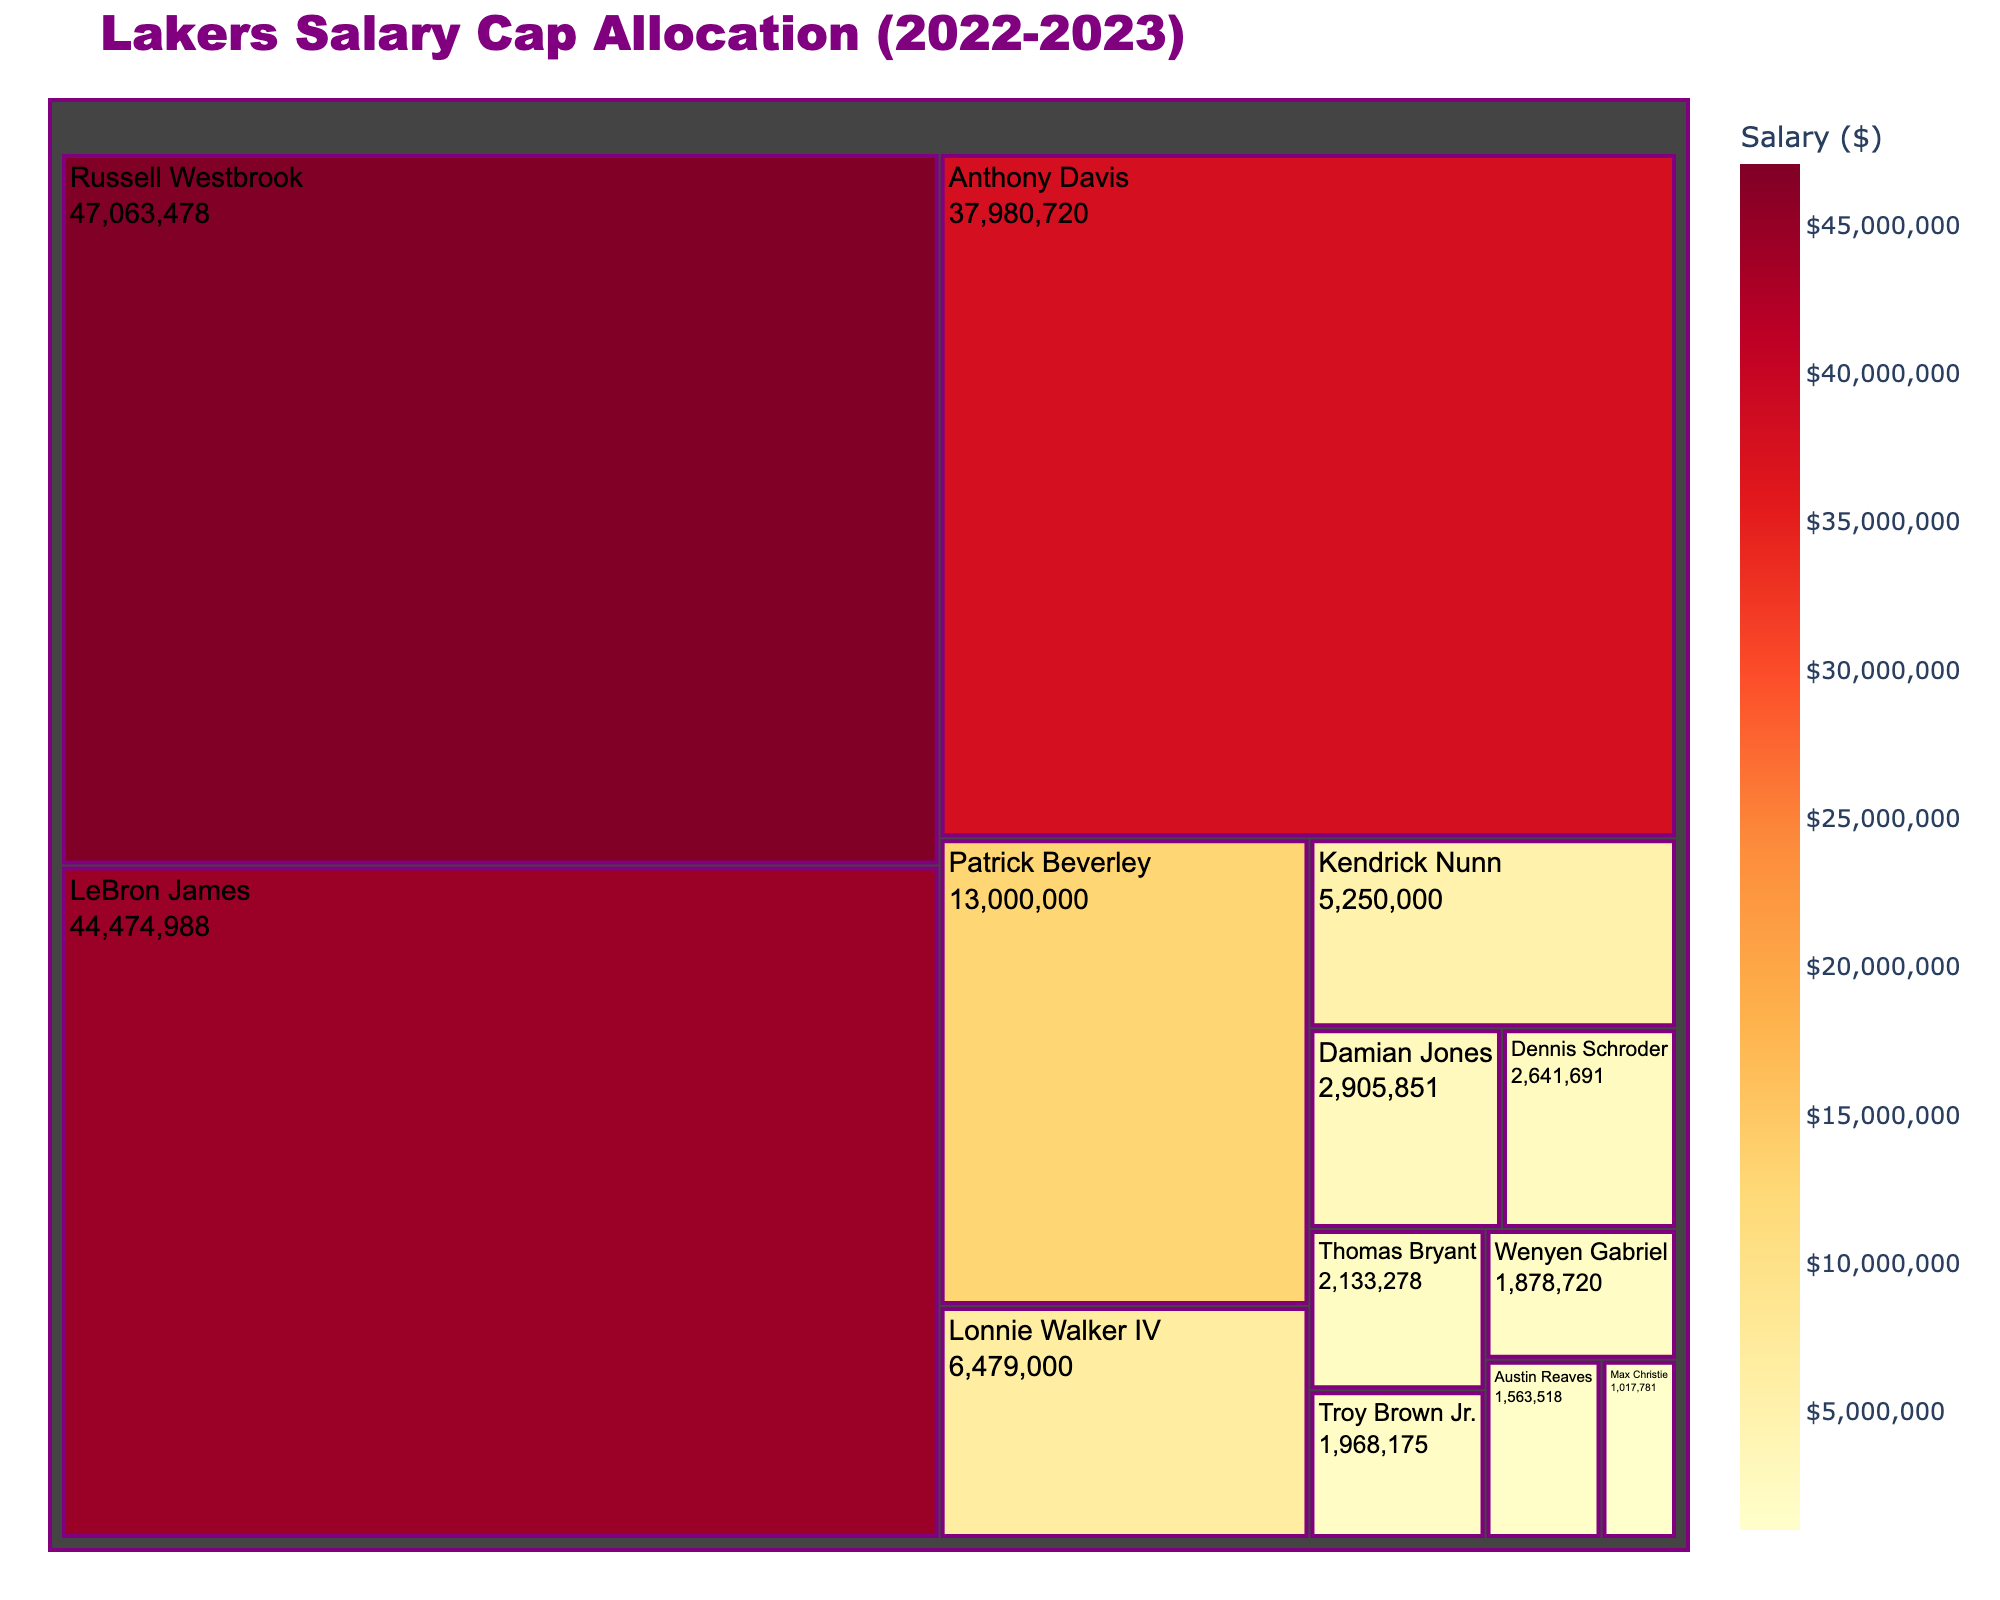What's the title of the figure? The title is usually found at the top of the figure. In this case, it reads "Lakers Salary Cap Allocation (2022-2023)".
Answer: Lakers Salary Cap Allocation (2022-2023) Which player has the highest salary? The largest and darkest colored block represents the player with the highest salary. In this treemap, Russell Westbrook's block is the largest and darkest.
Answer: Russell Westbrook How much is LeBron James' salary? Find LeBron James in the treemap and look at the value displayed within his block. The salary is shown as $44,474,988.
Answer: $44,474,988 What's the combined salary of Anthony Davis and Patrick Beverley? Locate the blocks for Anthony Davis and Patrick Beverley and sum their salaries: $37,980,720 + $13,000,000.
Answer: $50,980,720 Who has the lowest salary, and what is it? The smallest and lightest colored block represents the player with the lowest salary. Max Christie has the smallest block, indicating he has the lowest salary of $1,017,781.
Answer: Max Christie, $1,017,781 How does Dennis Schroder's salary compare to Kendrick Nunn's salary? Find both players in the treemap and compare their values. Dennis Schroder's salary is $2,641,691, while Kendrick Nunn's salary is $5,250,000. Schroder's salary is less than Nunn's.
Answer: Dennis Schroder's salary is less than Kendrick Nunn's What color represents the highest salary in the treemap? The treemap uses color to represent salary, with higher salaries shown in darker colors. The darkest color represents the highest salary.
Answer: Dark color What's the total salary for all players listed? Sum the salaries of all players: $44,474,988 + $47,063,478 + $37,980,720 + $5,250,000 + $13,000,000 + $6,479,000 + $2,641,691 + $1,563,518 + $1,968,175 + $1,878,720 + $2,133,278 + $2,905,851 + $1,017,781.
Answer: $167,357,200 What's the median salary of the players? List all salaries in ascending order and find the middle value. The ordered list is: $1,017,781, $1,563,518, $1,878,720, $1,968,175, $2,133,278, $2,641,691, $2,905,851, $5,250,000, $6,479,000, $13,000,000, $37,980,720, $44,474,988, $47,063,478. The median salary is the seventh value, $2,905,851.
Answer: $2,905,851 How does the sum of salaries for LeBron James and Russell Westbrook compare to the sum of all other players? Sum LeBron James' and Russell Westbrook's salaries: $44,474,988 + $47,063,478 = $91,538,466. Sum the salaries for all other players and compare: $167,357,200 - $91,538,466 = $75,818,734. The sum for LeBron James and Russell Westbrook is greater.
Answer: The sum for LeBron and Russell is greater 